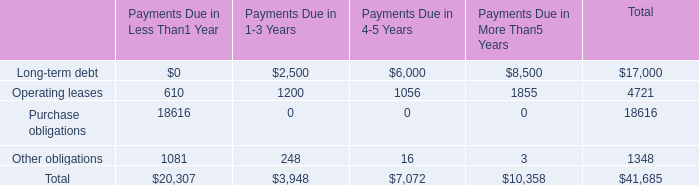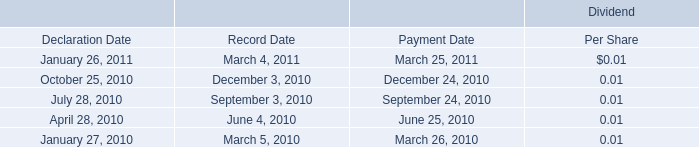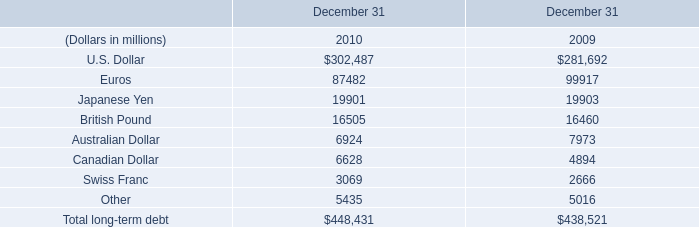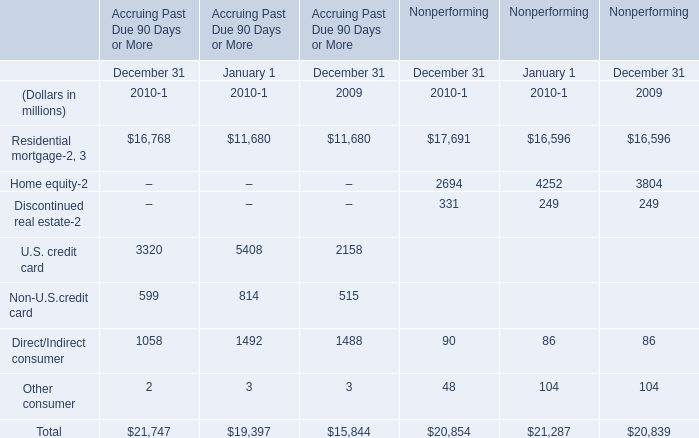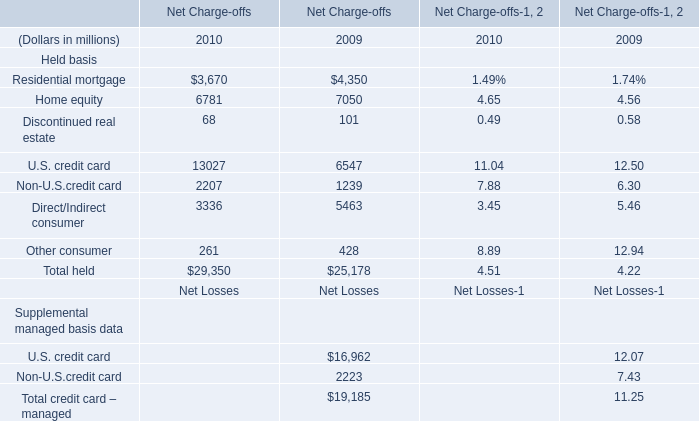What's the sum of Other obligations of Payments Due in Less Than1 Year, Canadian Dollar of December 31 2010, and Residential mortgage of Accruing Past Due 90 Days or More January 1 2010 ? 
Computations: ((1081.0 + 6628.0) + 11680.0)
Answer: 19389.0. 